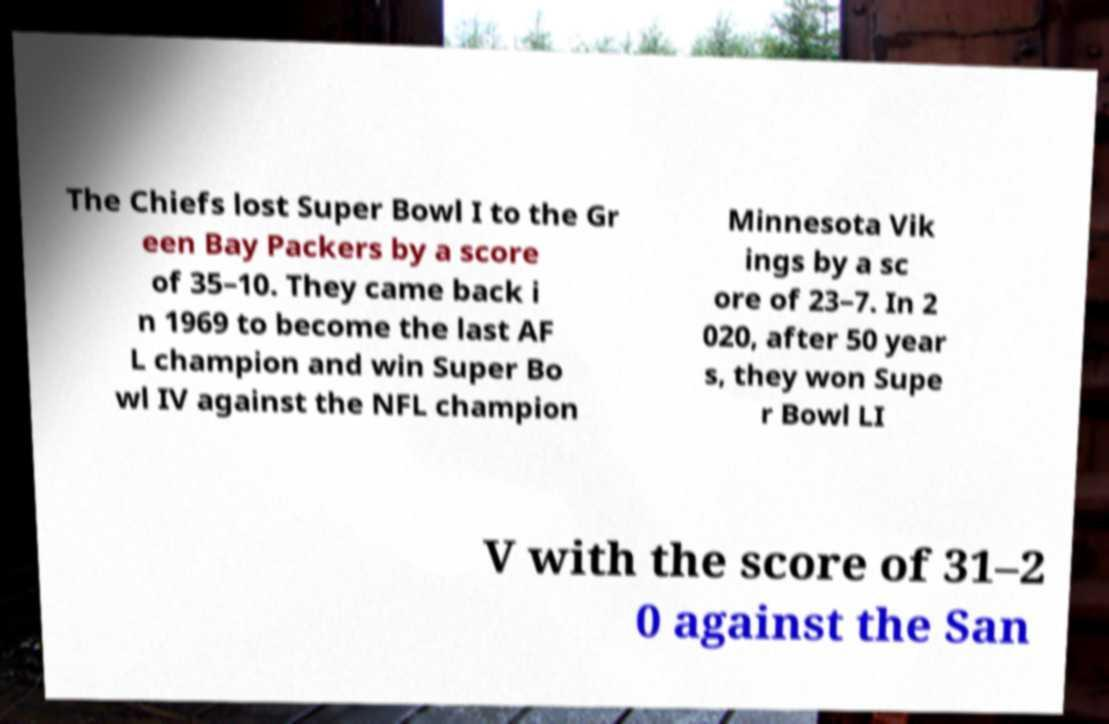For documentation purposes, I need the text within this image transcribed. Could you provide that? The Chiefs lost Super Bowl I to the Gr een Bay Packers by a score of 35–10. They came back i n 1969 to become the last AF L champion and win Super Bo wl IV against the NFL champion Minnesota Vik ings by a sc ore of 23–7. In 2 020, after 50 year s, they won Supe r Bowl LI V with the score of 31–2 0 against the San 